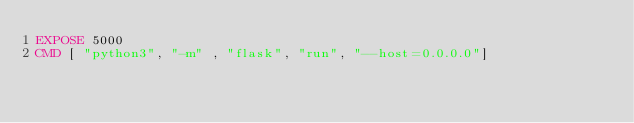<code> <loc_0><loc_0><loc_500><loc_500><_Dockerfile_>EXPOSE 5000
CMD [ "python3", "-m" , "flask", "run", "--host=0.0.0.0"]
</code> 